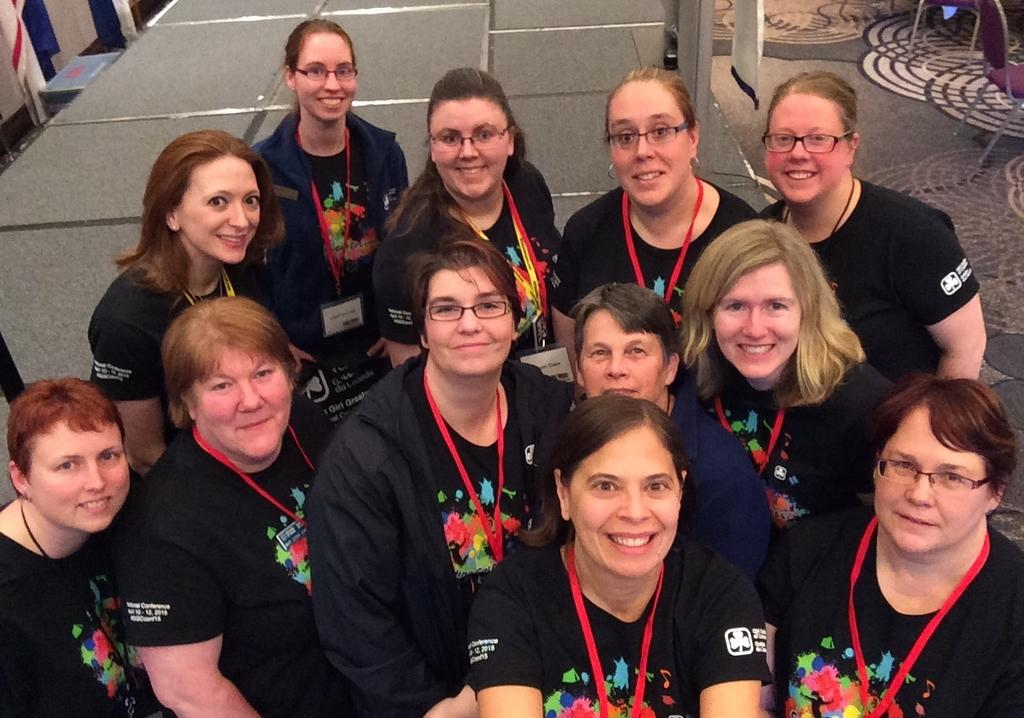Who or what can be seen in the image? There are people in the image. What are the people doing in the image? The people are smiling. What type of furniture is present in the image? There are chairs in the image. What part of the room can be seen in the image? The floor is visible in the image. What type of material is present in the image? There is cloth present in the image. What other objects can be seen in the image besides the people and chairs? There are other objects visible in the image. Can you tell me how many actors are visible in the image? There is no mention of actors in the image; it features people who are not necessarily actors. Is there an airplane visible in the image? No, there is no airplane present in the image. 